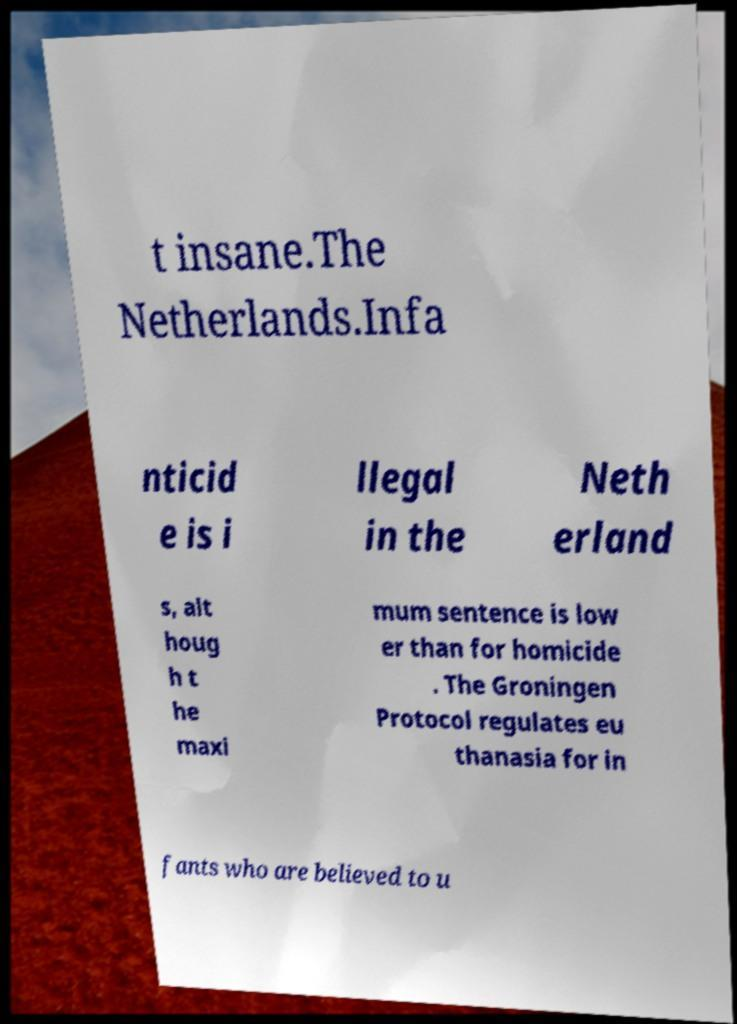Could you extract and type out the text from this image? t insane.The Netherlands.Infa nticid e is i llegal in the Neth erland s, alt houg h t he maxi mum sentence is low er than for homicide . The Groningen Protocol regulates eu thanasia for in fants who are believed to u 